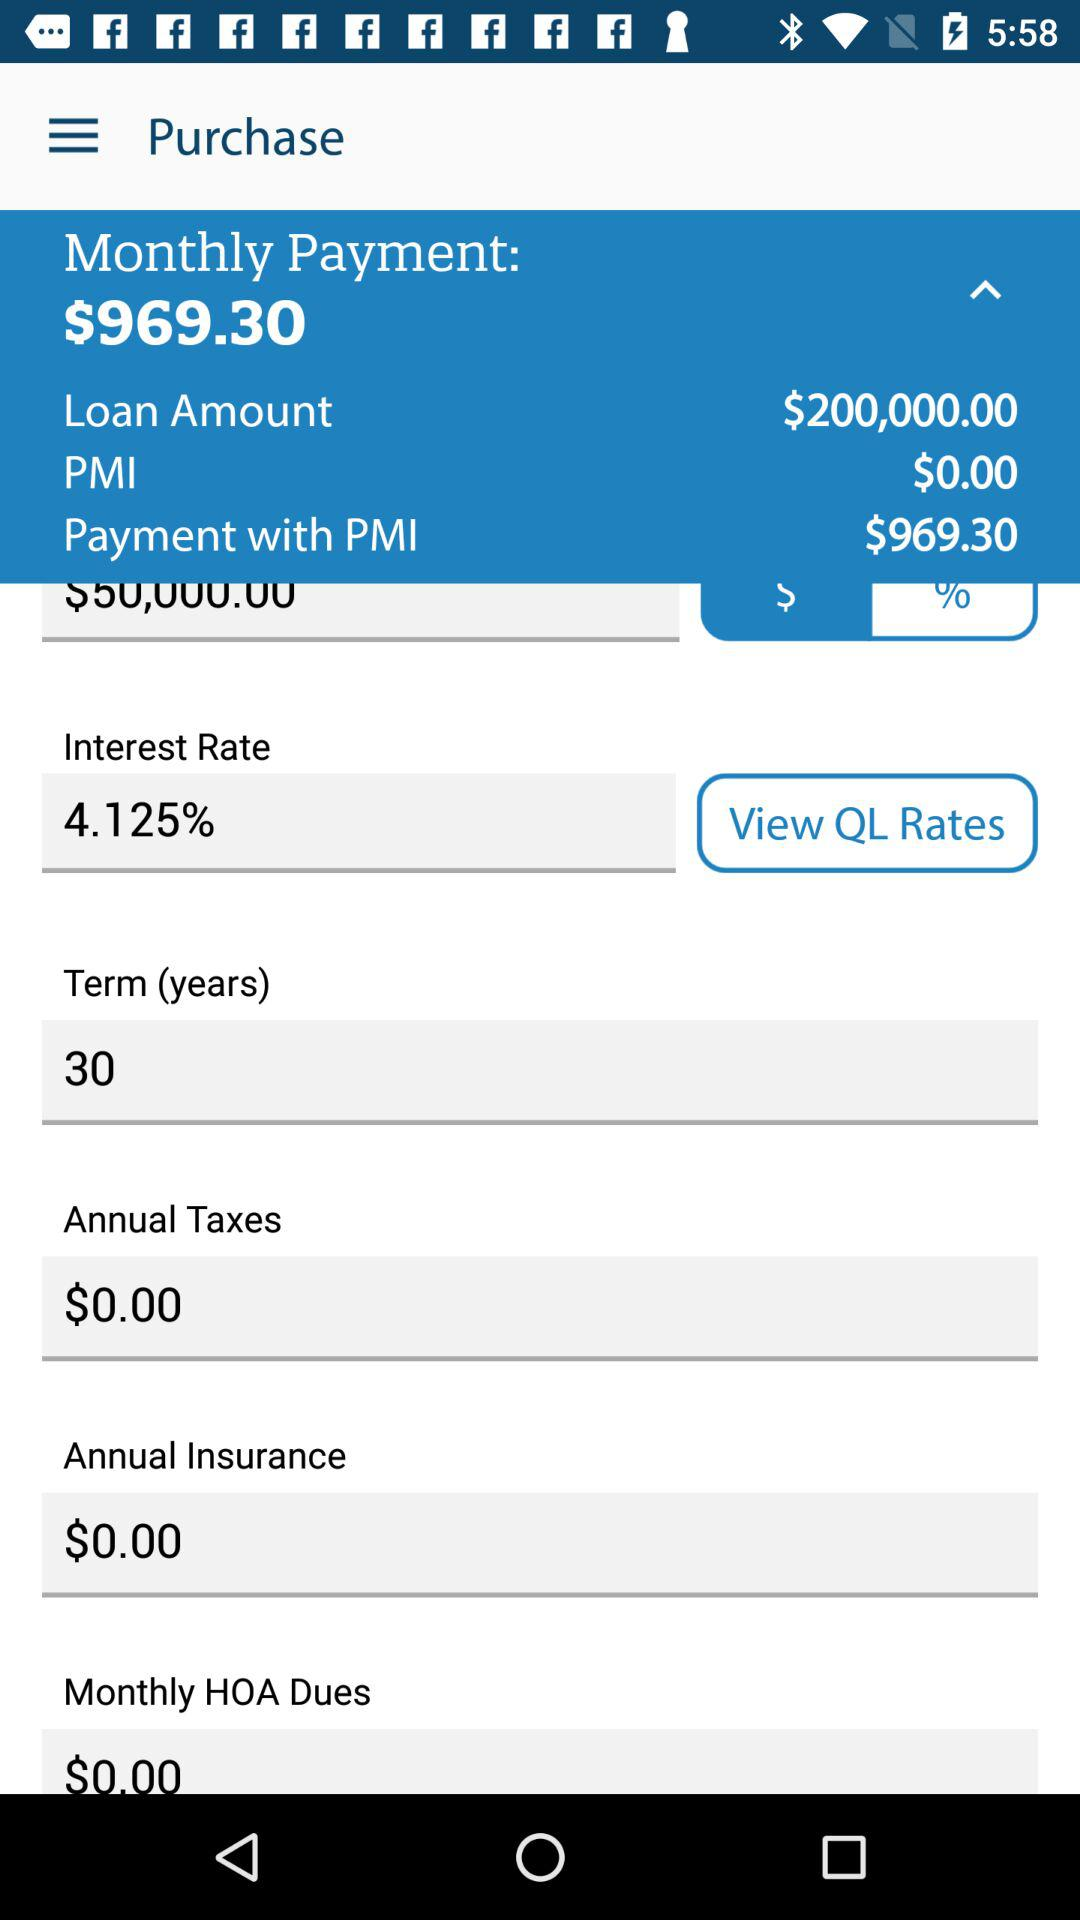How much is the annual insurance? The annual insurance is $0. 